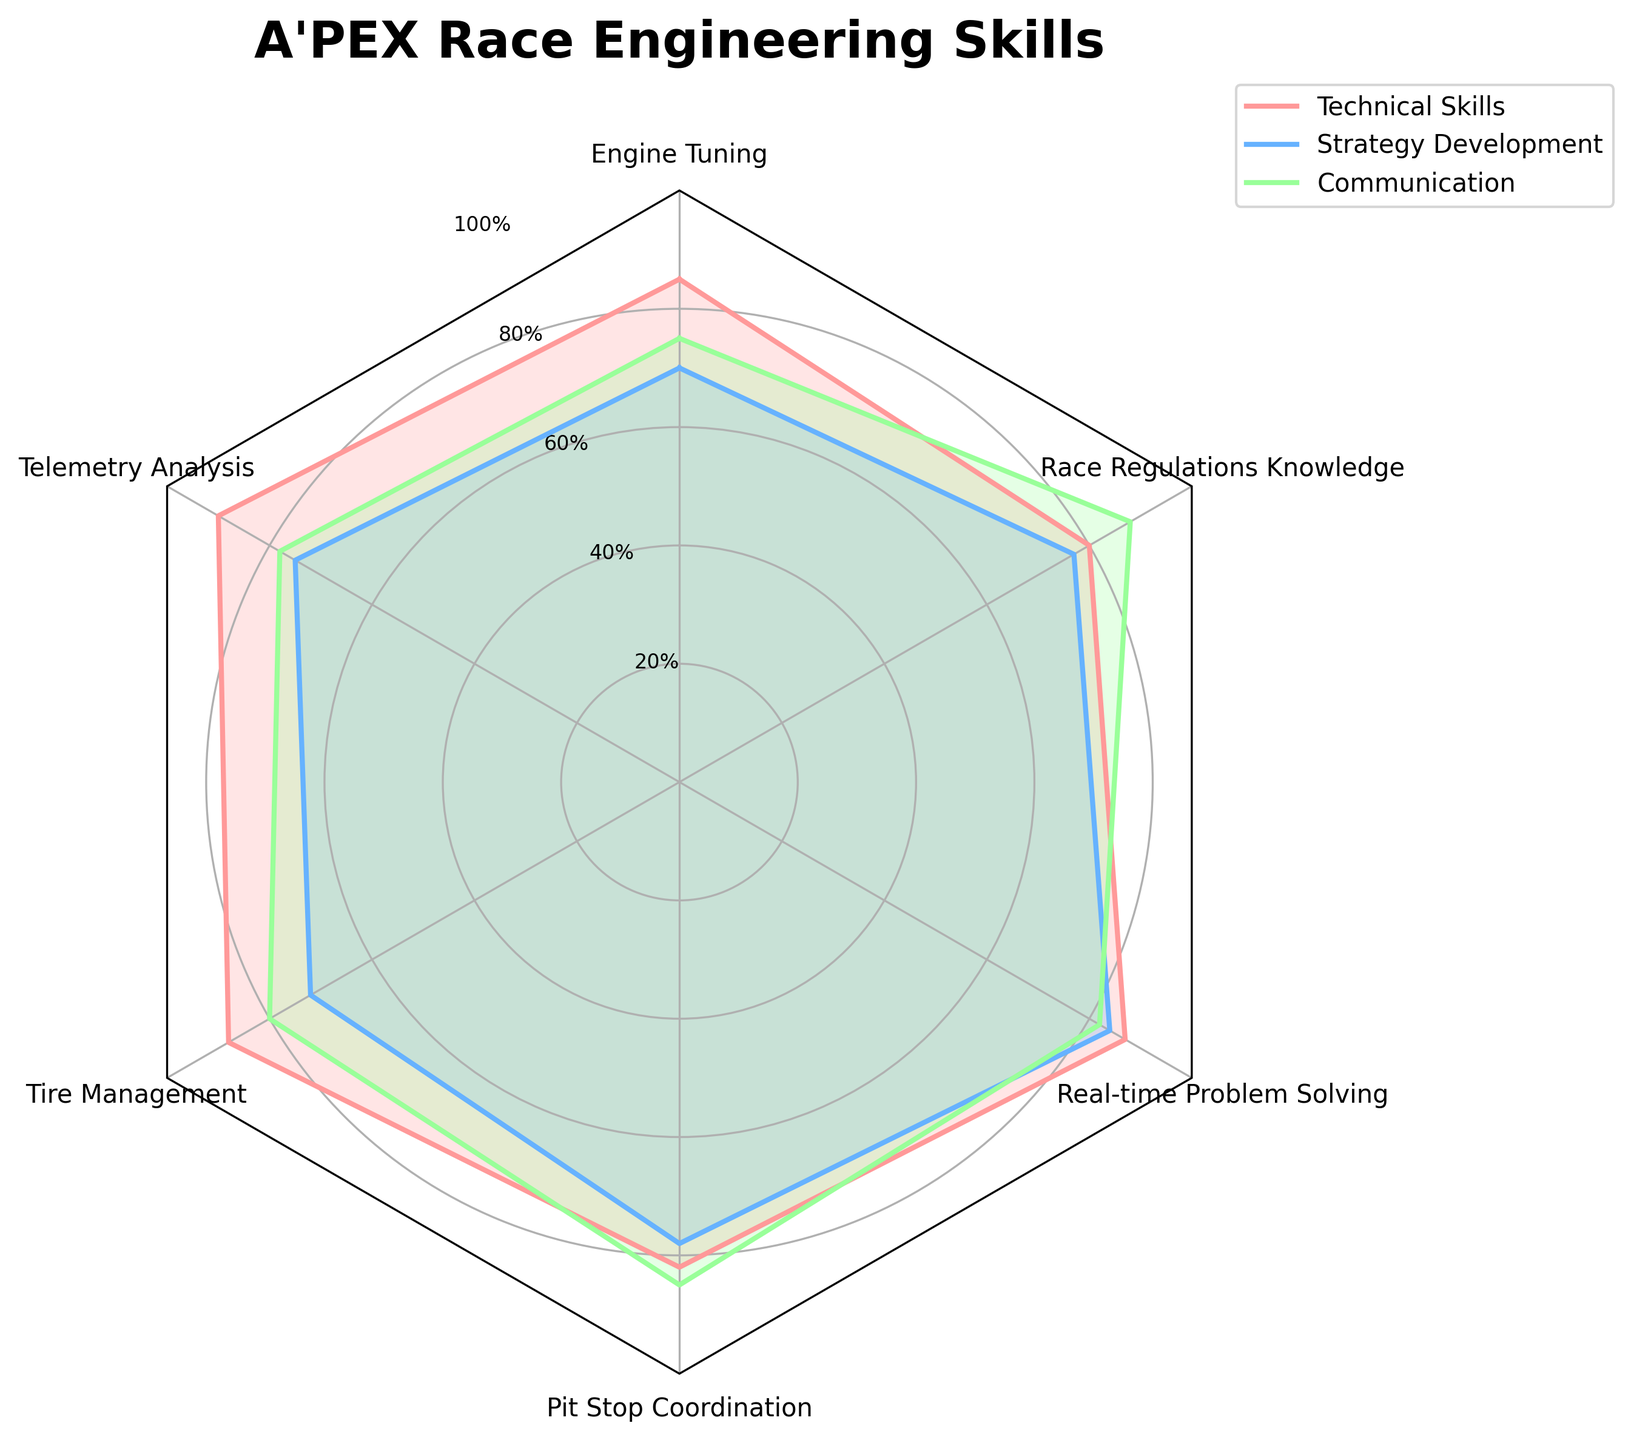Which skill category has the highest average value across all skills? To get the highest average value, calculate the average for each skill category. You add up all the values for each category and divide by the number of groups. Technical Skills: (85+90+88+82+87+80)/6 = 85.33, Strategy Development: (70+75+72+78+84+77)/6 = 76, Communication: (75+78+80+85+82+88)/6 = 81.33. The highest average value is for Technical Skills.
Answer: Technical Skills What is the title of the radar chart? The title of the radar chart is usually displayed at the top of the figure.
Answer: A'PEX Race Engineering Skills Which skill category scores the highest in Engine Tuning? Refer to the radar chart and look at the values for each category under Engine Tuning. The values are: Technical Skills: 85, Strategy Development: 70, Communication: 75. The highest value is for Technical Skills.
Answer: Technical Skills How many skill categories are displayed? The skill categories are represented by the different lines and shaded areas on the radar chart. Each category corresponds to a skill. Count the number of distinct skill categories plotted.
Answer: 3 What is the minimum score for Communication across all skills? Find the lowest value for Communication in the radar chart. The values across all skills for Communication are 75, 78, 80, 85, 82, and 88. The minimum score is 75.
Answer: 75 Which skill has the highest score in Adaptability? Look at the values for Adaptability for each skill. The values are Engine Tuning: 80, Telemetry Analysis: 85, Tire Management: 78, Pit Stop Coordination: 83, Real-time Problem Solving: 86, Race Regulations Knowledge: 79. The highest value is for Real-time Problem Solving.
Answer: Real-time Problem Solving Do Strategy Development and Communication ever have the same score for any skill? Compare the values of Strategy Development and Communication for each skill to see if there are any matches. The scores do not match for any skill.
Answer: No Which skill category shows a greater variance across the skills? Calculate the variance for each category. 
Technical Skills variance = ((85-85.33)^2+(90-85.33)^2+(88-85.33)^2+(82-85.33)^2+(87-85.33)^2+(80-85.33)^2)/6 ≈ 11.22,
Strategy Development variance = ((70-76)^2+(75-76)^2+(72-76)^2+(78-76)^2+(84-76)^2+(77-76)^2)/6 ≈ 14.67,
Communication variance = ((75-81.33)^2+(78-81.33)^2+(80-81.33)^2+(85-81.33)^2+(82-81.33)^2+(88-81.33)^2)/6 ≈ 17.22.
Communication has the highest variance.
Answer: Communication What is the median score for Technical Skills? To find the median score, sort the Technical Skills scores: 80, 82, 85, 87, 88, 90. The median is the middle value, which can be calculated as (85+87)/2 = 86.
Answer: 86 Which skill category has the smallest total sum across all skills? Sum up the values for each skill category.
Technical Skills total = 85+90+88+82+87+80 = 512,
Strategy Development total = 70+75+72+78+84+77 = 456,
Communication total = 75+78+80+85+82+88 = 488.
Strategy Development has the smallest total sum.
Answer: Strategy Development 